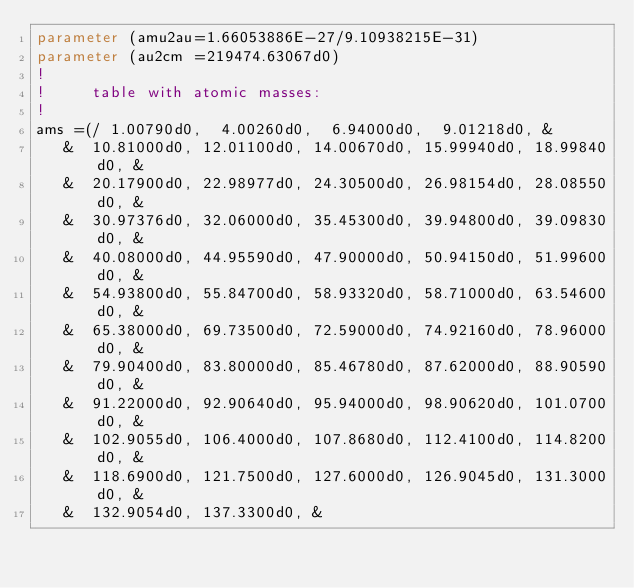<code> <loc_0><loc_0><loc_500><loc_500><_FORTRAN_>parameter (amu2au=1.66053886E-27/9.10938215E-31)
parameter (au2cm =219474.63067d0)                      
!
!     table with atomic masses:
!
ams =(/ 1.00790d0,  4.00260d0,  6.94000d0,  9.01218d0, &
   &  10.81000d0, 12.01100d0, 14.00670d0, 15.99940d0, 18.99840d0, &
   &  20.17900d0, 22.98977d0, 24.30500d0, 26.98154d0, 28.08550d0, &
   &  30.97376d0, 32.06000d0, 35.45300d0, 39.94800d0, 39.09830d0, &
   &  40.08000d0, 44.95590d0, 47.90000d0, 50.94150d0, 51.99600d0, &
   &  54.93800d0, 55.84700d0, 58.93320d0, 58.71000d0, 63.54600d0, & 
   &  65.38000d0, 69.73500d0, 72.59000d0, 74.92160d0, 78.96000d0, &
   &  79.90400d0, 83.80000d0, 85.46780d0, 87.62000d0, 88.90590d0, &
   &  91.22000d0, 92.90640d0, 95.94000d0, 98.90620d0, 101.0700d0, &
   &  102.9055d0, 106.4000d0, 107.8680d0, 112.4100d0, 114.8200d0, &
   &  118.6900d0, 121.7500d0, 127.6000d0, 126.9045d0, 131.3000d0, &
   &  132.9054d0, 137.3300d0, &</code> 